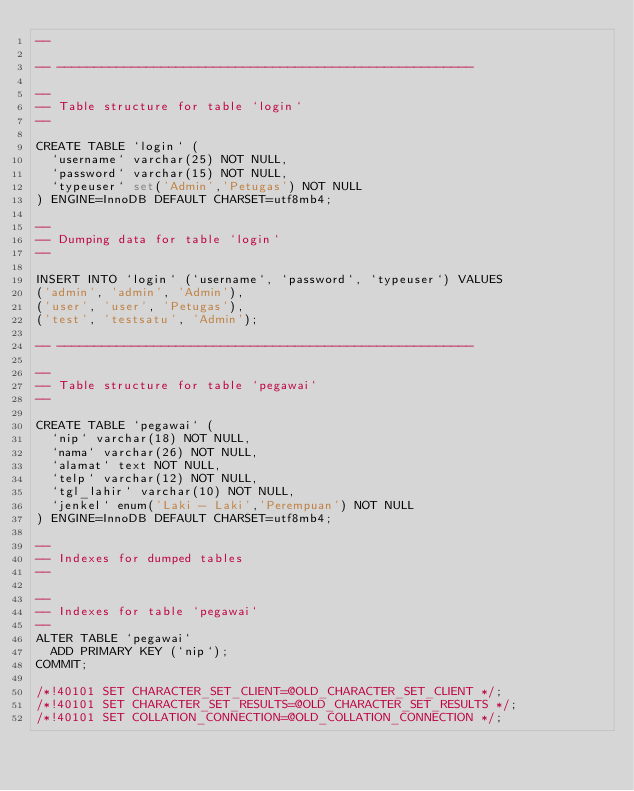<code> <loc_0><loc_0><loc_500><loc_500><_SQL_>--

-- --------------------------------------------------------

--
-- Table structure for table `login`
--

CREATE TABLE `login` (
  `username` varchar(25) NOT NULL,
  `password` varchar(15) NOT NULL,
  `typeuser` set('Admin','Petugas') NOT NULL
) ENGINE=InnoDB DEFAULT CHARSET=utf8mb4;

--
-- Dumping data for table `login`
--

INSERT INTO `login` (`username`, `password`, `typeuser`) VALUES
('admin', 'admin', 'Admin'),
('user', 'user', 'Petugas'),
('test', 'testsatu', 'Admin');

-- --------------------------------------------------------

--
-- Table structure for table `pegawai`
--

CREATE TABLE `pegawai` (
  `nip` varchar(18) NOT NULL,
  `nama` varchar(26) NOT NULL,
  `alamat` text NOT NULL,
  `telp` varchar(12) NOT NULL,
  `tgl_lahir` varchar(10) NOT NULL,
  `jenkel` enum('Laki - Laki','Perempuan') NOT NULL
) ENGINE=InnoDB DEFAULT CHARSET=utf8mb4;

--
-- Indexes for dumped tables
--

--
-- Indexes for table `pegawai`
--
ALTER TABLE `pegawai`
  ADD PRIMARY KEY (`nip`);
COMMIT;

/*!40101 SET CHARACTER_SET_CLIENT=@OLD_CHARACTER_SET_CLIENT */;
/*!40101 SET CHARACTER_SET_RESULTS=@OLD_CHARACTER_SET_RESULTS */;
/*!40101 SET COLLATION_CONNECTION=@OLD_COLLATION_CONNECTION */;
</code> 